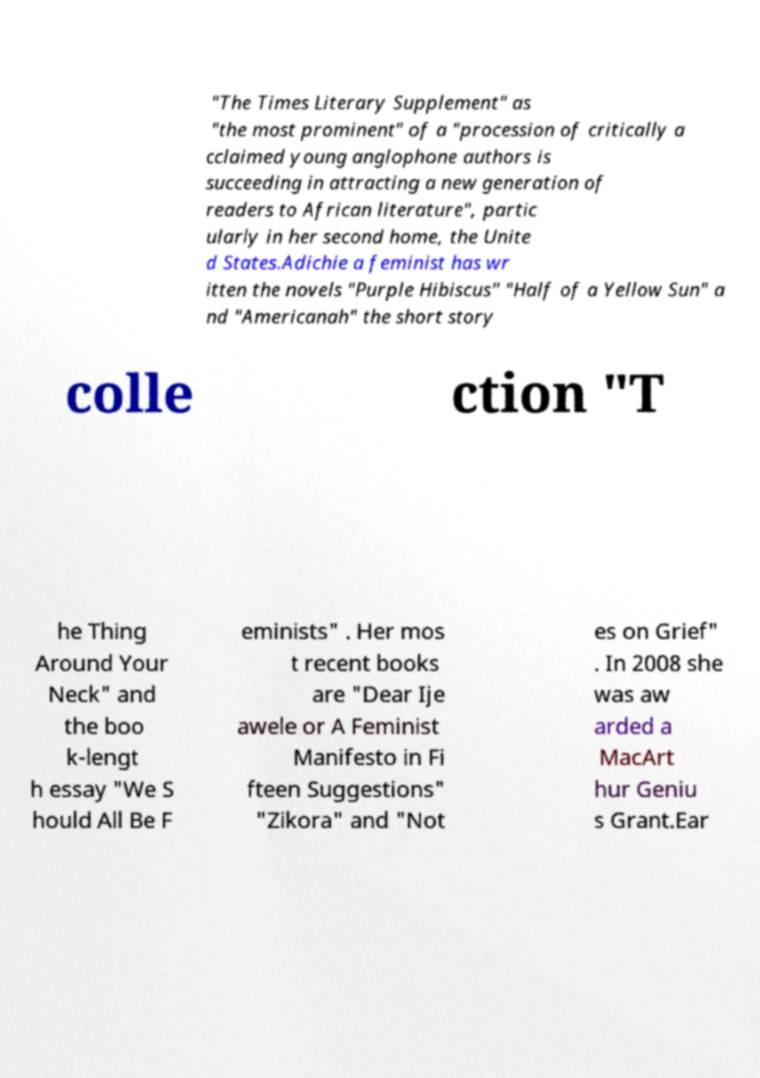There's text embedded in this image that I need extracted. Can you transcribe it verbatim? "The Times Literary Supplement" as "the most prominent" of a "procession of critically a cclaimed young anglophone authors is succeeding in attracting a new generation of readers to African literature", partic ularly in her second home, the Unite d States.Adichie a feminist has wr itten the novels "Purple Hibiscus" "Half of a Yellow Sun" a nd "Americanah" the short story colle ction "T he Thing Around Your Neck" and the boo k-lengt h essay "We S hould All Be F eminists" . Her mos t recent books are "Dear Ije awele or A Feminist Manifesto in Fi fteen Suggestions" "Zikora" and "Not es on Grief" . In 2008 she was aw arded a MacArt hur Geniu s Grant.Ear 